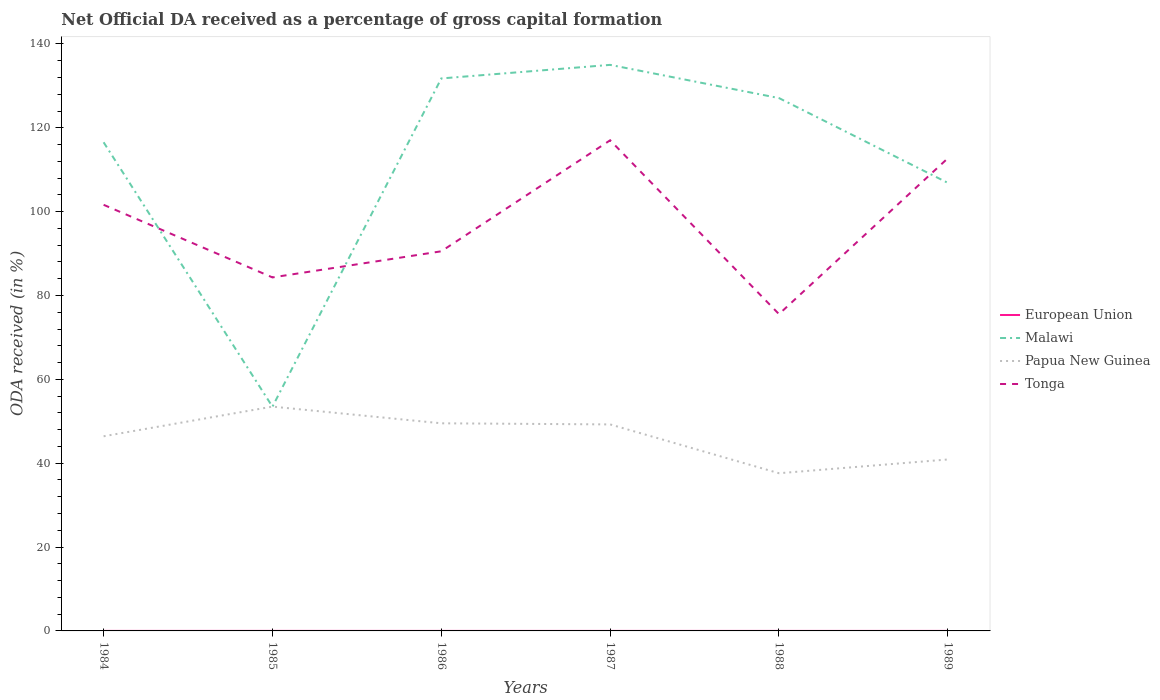Is the number of lines equal to the number of legend labels?
Offer a very short reply. Yes. Across all years, what is the maximum net ODA received in Papua New Guinea?
Your answer should be compact. 37.61. In which year was the net ODA received in European Union maximum?
Make the answer very short. 1989. What is the total net ODA received in Malawi in the graph?
Your answer should be compact. -53.38. What is the difference between the highest and the second highest net ODA received in Papua New Guinea?
Ensure brevity in your answer.  15.89. Is the net ODA received in Papua New Guinea strictly greater than the net ODA received in Malawi over the years?
Keep it short and to the point. No. How many lines are there?
Your response must be concise. 4. How many years are there in the graph?
Offer a very short reply. 6. What is the difference between two consecutive major ticks on the Y-axis?
Make the answer very short. 20. Are the values on the major ticks of Y-axis written in scientific E-notation?
Offer a terse response. No. Does the graph contain grids?
Your answer should be compact. No. What is the title of the graph?
Give a very brief answer. Net Official DA received as a percentage of gross capital formation. Does "Morocco" appear as one of the legend labels in the graph?
Provide a short and direct response. No. What is the label or title of the Y-axis?
Offer a terse response. ODA received (in %). What is the ODA received (in %) in European Union in 1984?
Keep it short and to the point. 0. What is the ODA received (in %) in Malawi in 1984?
Your response must be concise. 116.54. What is the ODA received (in %) of Papua New Guinea in 1984?
Your answer should be compact. 46.42. What is the ODA received (in %) of Tonga in 1984?
Offer a very short reply. 101.63. What is the ODA received (in %) of European Union in 1985?
Your answer should be compact. 0.01. What is the ODA received (in %) of Malawi in 1985?
Give a very brief answer. 53.48. What is the ODA received (in %) in Papua New Guinea in 1985?
Keep it short and to the point. 53.5. What is the ODA received (in %) in Tonga in 1985?
Your response must be concise. 84.31. What is the ODA received (in %) in European Union in 1986?
Keep it short and to the point. 0. What is the ODA received (in %) in Malawi in 1986?
Offer a terse response. 131.77. What is the ODA received (in %) in Papua New Guinea in 1986?
Ensure brevity in your answer.  49.52. What is the ODA received (in %) in Tonga in 1986?
Offer a terse response. 90.54. What is the ODA received (in %) in European Union in 1987?
Offer a very short reply. 0. What is the ODA received (in %) of Malawi in 1987?
Offer a very short reply. 135. What is the ODA received (in %) in Papua New Guinea in 1987?
Offer a very short reply. 49.25. What is the ODA received (in %) in Tonga in 1987?
Provide a succinct answer. 117.01. What is the ODA received (in %) of European Union in 1988?
Offer a very short reply. 0. What is the ODA received (in %) of Malawi in 1988?
Keep it short and to the point. 127.08. What is the ODA received (in %) of Papua New Guinea in 1988?
Make the answer very short. 37.61. What is the ODA received (in %) of Tonga in 1988?
Offer a terse response. 75.56. What is the ODA received (in %) in European Union in 1989?
Make the answer very short. 0. What is the ODA received (in %) of Malawi in 1989?
Your answer should be compact. 106.86. What is the ODA received (in %) in Papua New Guinea in 1989?
Your answer should be compact. 40.89. What is the ODA received (in %) of Tonga in 1989?
Keep it short and to the point. 112.73. Across all years, what is the maximum ODA received (in %) of European Union?
Your answer should be compact. 0.01. Across all years, what is the maximum ODA received (in %) in Malawi?
Provide a short and direct response. 135. Across all years, what is the maximum ODA received (in %) in Papua New Guinea?
Give a very brief answer. 53.5. Across all years, what is the maximum ODA received (in %) in Tonga?
Provide a short and direct response. 117.01. Across all years, what is the minimum ODA received (in %) in European Union?
Your answer should be very brief. 0. Across all years, what is the minimum ODA received (in %) in Malawi?
Give a very brief answer. 53.48. Across all years, what is the minimum ODA received (in %) of Papua New Guinea?
Offer a terse response. 37.61. Across all years, what is the minimum ODA received (in %) of Tonga?
Offer a very short reply. 75.56. What is the total ODA received (in %) in European Union in the graph?
Give a very brief answer. 0.02. What is the total ODA received (in %) in Malawi in the graph?
Your response must be concise. 670.73. What is the total ODA received (in %) of Papua New Guinea in the graph?
Provide a succinct answer. 277.19. What is the total ODA received (in %) in Tonga in the graph?
Give a very brief answer. 581.78. What is the difference between the ODA received (in %) in European Union in 1984 and that in 1985?
Your answer should be very brief. -0. What is the difference between the ODA received (in %) of Malawi in 1984 and that in 1985?
Ensure brevity in your answer.  63.06. What is the difference between the ODA received (in %) of Papua New Guinea in 1984 and that in 1985?
Provide a succinct answer. -7.08. What is the difference between the ODA received (in %) in Tonga in 1984 and that in 1985?
Provide a short and direct response. 17.32. What is the difference between the ODA received (in %) of European Union in 1984 and that in 1986?
Give a very brief answer. -0. What is the difference between the ODA received (in %) of Malawi in 1984 and that in 1986?
Your answer should be very brief. -15.22. What is the difference between the ODA received (in %) of Papua New Guinea in 1984 and that in 1986?
Your answer should be compact. -3.09. What is the difference between the ODA received (in %) in Tonga in 1984 and that in 1986?
Give a very brief answer. 11.09. What is the difference between the ODA received (in %) of European Union in 1984 and that in 1987?
Offer a very short reply. 0. What is the difference between the ODA received (in %) in Malawi in 1984 and that in 1987?
Your answer should be compact. -18.46. What is the difference between the ODA received (in %) in Papua New Guinea in 1984 and that in 1987?
Your answer should be very brief. -2.83. What is the difference between the ODA received (in %) of Tonga in 1984 and that in 1987?
Provide a succinct answer. -15.39. What is the difference between the ODA received (in %) of European Union in 1984 and that in 1988?
Your response must be concise. 0. What is the difference between the ODA received (in %) in Malawi in 1984 and that in 1988?
Your answer should be compact. -10.54. What is the difference between the ODA received (in %) of Papua New Guinea in 1984 and that in 1988?
Give a very brief answer. 8.81. What is the difference between the ODA received (in %) in Tonga in 1984 and that in 1988?
Your answer should be compact. 26.07. What is the difference between the ODA received (in %) of European Union in 1984 and that in 1989?
Make the answer very short. 0. What is the difference between the ODA received (in %) of Malawi in 1984 and that in 1989?
Offer a very short reply. 9.68. What is the difference between the ODA received (in %) in Papua New Guinea in 1984 and that in 1989?
Give a very brief answer. 5.53. What is the difference between the ODA received (in %) of Tonga in 1984 and that in 1989?
Your response must be concise. -11.1. What is the difference between the ODA received (in %) of European Union in 1985 and that in 1986?
Your answer should be compact. 0. What is the difference between the ODA received (in %) in Malawi in 1985 and that in 1986?
Make the answer very short. -78.29. What is the difference between the ODA received (in %) of Papua New Guinea in 1985 and that in 1986?
Offer a very short reply. 3.98. What is the difference between the ODA received (in %) in Tonga in 1985 and that in 1986?
Provide a short and direct response. -6.23. What is the difference between the ODA received (in %) of European Union in 1985 and that in 1987?
Make the answer very short. 0. What is the difference between the ODA received (in %) in Malawi in 1985 and that in 1987?
Your response must be concise. -81.52. What is the difference between the ODA received (in %) of Papua New Guinea in 1985 and that in 1987?
Ensure brevity in your answer.  4.25. What is the difference between the ODA received (in %) in Tonga in 1985 and that in 1987?
Provide a short and direct response. -32.7. What is the difference between the ODA received (in %) of European Union in 1985 and that in 1988?
Keep it short and to the point. 0. What is the difference between the ODA received (in %) of Malawi in 1985 and that in 1988?
Give a very brief answer. -73.6. What is the difference between the ODA received (in %) in Papua New Guinea in 1985 and that in 1988?
Offer a terse response. 15.89. What is the difference between the ODA received (in %) in Tonga in 1985 and that in 1988?
Your answer should be very brief. 8.75. What is the difference between the ODA received (in %) of European Union in 1985 and that in 1989?
Offer a terse response. 0.01. What is the difference between the ODA received (in %) in Malawi in 1985 and that in 1989?
Offer a very short reply. -53.38. What is the difference between the ODA received (in %) of Papua New Guinea in 1985 and that in 1989?
Your answer should be very brief. 12.61. What is the difference between the ODA received (in %) in Tonga in 1985 and that in 1989?
Keep it short and to the point. -28.42. What is the difference between the ODA received (in %) in Malawi in 1986 and that in 1987?
Keep it short and to the point. -3.24. What is the difference between the ODA received (in %) of Papua New Guinea in 1986 and that in 1987?
Offer a very short reply. 0.27. What is the difference between the ODA received (in %) in Tonga in 1986 and that in 1987?
Give a very brief answer. -26.47. What is the difference between the ODA received (in %) of European Union in 1986 and that in 1988?
Provide a short and direct response. 0. What is the difference between the ODA received (in %) of Malawi in 1986 and that in 1988?
Your response must be concise. 4.68. What is the difference between the ODA received (in %) in Papua New Guinea in 1986 and that in 1988?
Make the answer very short. 11.91. What is the difference between the ODA received (in %) of Tonga in 1986 and that in 1988?
Offer a terse response. 14.98. What is the difference between the ODA received (in %) in European Union in 1986 and that in 1989?
Keep it short and to the point. 0. What is the difference between the ODA received (in %) in Malawi in 1986 and that in 1989?
Provide a short and direct response. 24.9. What is the difference between the ODA received (in %) of Papua New Guinea in 1986 and that in 1989?
Keep it short and to the point. 8.63. What is the difference between the ODA received (in %) in Tonga in 1986 and that in 1989?
Keep it short and to the point. -22.19. What is the difference between the ODA received (in %) in Malawi in 1987 and that in 1988?
Offer a terse response. 7.92. What is the difference between the ODA received (in %) in Papua New Guinea in 1987 and that in 1988?
Give a very brief answer. 11.64. What is the difference between the ODA received (in %) in Tonga in 1987 and that in 1988?
Give a very brief answer. 41.46. What is the difference between the ODA received (in %) in European Union in 1987 and that in 1989?
Offer a terse response. 0. What is the difference between the ODA received (in %) in Malawi in 1987 and that in 1989?
Your answer should be very brief. 28.14. What is the difference between the ODA received (in %) of Papua New Guinea in 1987 and that in 1989?
Offer a terse response. 8.36. What is the difference between the ODA received (in %) in Tonga in 1987 and that in 1989?
Make the answer very short. 4.29. What is the difference between the ODA received (in %) of European Union in 1988 and that in 1989?
Your answer should be compact. 0. What is the difference between the ODA received (in %) of Malawi in 1988 and that in 1989?
Offer a terse response. 20.22. What is the difference between the ODA received (in %) of Papua New Guinea in 1988 and that in 1989?
Provide a succinct answer. -3.28. What is the difference between the ODA received (in %) in Tonga in 1988 and that in 1989?
Make the answer very short. -37.17. What is the difference between the ODA received (in %) of European Union in 1984 and the ODA received (in %) of Malawi in 1985?
Your answer should be very brief. -53.48. What is the difference between the ODA received (in %) of European Union in 1984 and the ODA received (in %) of Papua New Guinea in 1985?
Offer a very short reply. -53.49. What is the difference between the ODA received (in %) in European Union in 1984 and the ODA received (in %) in Tonga in 1985?
Your answer should be very brief. -84.31. What is the difference between the ODA received (in %) of Malawi in 1984 and the ODA received (in %) of Papua New Guinea in 1985?
Make the answer very short. 63.04. What is the difference between the ODA received (in %) of Malawi in 1984 and the ODA received (in %) of Tonga in 1985?
Your answer should be compact. 32.23. What is the difference between the ODA received (in %) in Papua New Guinea in 1984 and the ODA received (in %) in Tonga in 1985?
Keep it short and to the point. -37.89. What is the difference between the ODA received (in %) of European Union in 1984 and the ODA received (in %) of Malawi in 1986?
Give a very brief answer. -131.76. What is the difference between the ODA received (in %) in European Union in 1984 and the ODA received (in %) in Papua New Guinea in 1986?
Your answer should be compact. -49.51. What is the difference between the ODA received (in %) of European Union in 1984 and the ODA received (in %) of Tonga in 1986?
Keep it short and to the point. -90.54. What is the difference between the ODA received (in %) of Malawi in 1984 and the ODA received (in %) of Papua New Guinea in 1986?
Ensure brevity in your answer.  67.02. What is the difference between the ODA received (in %) of Malawi in 1984 and the ODA received (in %) of Tonga in 1986?
Provide a succinct answer. 26. What is the difference between the ODA received (in %) of Papua New Guinea in 1984 and the ODA received (in %) of Tonga in 1986?
Ensure brevity in your answer.  -44.12. What is the difference between the ODA received (in %) in European Union in 1984 and the ODA received (in %) in Malawi in 1987?
Your response must be concise. -135. What is the difference between the ODA received (in %) of European Union in 1984 and the ODA received (in %) of Papua New Guinea in 1987?
Ensure brevity in your answer.  -49.25. What is the difference between the ODA received (in %) in European Union in 1984 and the ODA received (in %) in Tonga in 1987?
Give a very brief answer. -117.01. What is the difference between the ODA received (in %) in Malawi in 1984 and the ODA received (in %) in Papua New Guinea in 1987?
Offer a terse response. 67.29. What is the difference between the ODA received (in %) in Malawi in 1984 and the ODA received (in %) in Tonga in 1987?
Provide a short and direct response. -0.47. What is the difference between the ODA received (in %) of Papua New Guinea in 1984 and the ODA received (in %) of Tonga in 1987?
Keep it short and to the point. -70.59. What is the difference between the ODA received (in %) in European Union in 1984 and the ODA received (in %) in Malawi in 1988?
Offer a very short reply. -127.08. What is the difference between the ODA received (in %) in European Union in 1984 and the ODA received (in %) in Papua New Guinea in 1988?
Keep it short and to the point. -37.61. What is the difference between the ODA received (in %) in European Union in 1984 and the ODA received (in %) in Tonga in 1988?
Ensure brevity in your answer.  -75.55. What is the difference between the ODA received (in %) of Malawi in 1984 and the ODA received (in %) of Papua New Guinea in 1988?
Offer a very short reply. 78.93. What is the difference between the ODA received (in %) in Malawi in 1984 and the ODA received (in %) in Tonga in 1988?
Your answer should be very brief. 40.98. What is the difference between the ODA received (in %) in Papua New Guinea in 1984 and the ODA received (in %) in Tonga in 1988?
Ensure brevity in your answer.  -29.13. What is the difference between the ODA received (in %) in European Union in 1984 and the ODA received (in %) in Malawi in 1989?
Keep it short and to the point. -106.86. What is the difference between the ODA received (in %) of European Union in 1984 and the ODA received (in %) of Papua New Guinea in 1989?
Provide a succinct answer. -40.89. What is the difference between the ODA received (in %) in European Union in 1984 and the ODA received (in %) in Tonga in 1989?
Provide a short and direct response. -112.72. What is the difference between the ODA received (in %) of Malawi in 1984 and the ODA received (in %) of Papua New Guinea in 1989?
Make the answer very short. 75.65. What is the difference between the ODA received (in %) of Malawi in 1984 and the ODA received (in %) of Tonga in 1989?
Your answer should be compact. 3.81. What is the difference between the ODA received (in %) in Papua New Guinea in 1984 and the ODA received (in %) in Tonga in 1989?
Offer a terse response. -66.31. What is the difference between the ODA received (in %) in European Union in 1985 and the ODA received (in %) in Malawi in 1986?
Give a very brief answer. -131.76. What is the difference between the ODA received (in %) in European Union in 1985 and the ODA received (in %) in Papua New Guinea in 1986?
Provide a succinct answer. -49.51. What is the difference between the ODA received (in %) in European Union in 1985 and the ODA received (in %) in Tonga in 1986?
Provide a succinct answer. -90.53. What is the difference between the ODA received (in %) of Malawi in 1985 and the ODA received (in %) of Papua New Guinea in 1986?
Offer a terse response. 3.96. What is the difference between the ODA received (in %) of Malawi in 1985 and the ODA received (in %) of Tonga in 1986?
Your answer should be very brief. -37.06. What is the difference between the ODA received (in %) in Papua New Guinea in 1985 and the ODA received (in %) in Tonga in 1986?
Your response must be concise. -37.04. What is the difference between the ODA received (in %) in European Union in 1985 and the ODA received (in %) in Malawi in 1987?
Ensure brevity in your answer.  -134.99. What is the difference between the ODA received (in %) of European Union in 1985 and the ODA received (in %) of Papua New Guinea in 1987?
Provide a short and direct response. -49.24. What is the difference between the ODA received (in %) of European Union in 1985 and the ODA received (in %) of Tonga in 1987?
Provide a succinct answer. -117.01. What is the difference between the ODA received (in %) of Malawi in 1985 and the ODA received (in %) of Papua New Guinea in 1987?
Give a very brief answer. 4.23. What is the difference between the ODA received (in %) in Malawi in 1985 and the ODA received (in %) in Tonga in 1987?
Keep it short and to the point. -63.53. What is the difference between the ODA received (in %) in Papua New Guinea in 1985 and the ODA received (in %) in Tonga in 1987?
Give a very brief answer. -63.52. What is the difference between the ODA received (in %) of European Union in 1985 and the ODA received (in %) of Malawi in 1988?
Offer a very short reply. -127.08. What is the difference between the ODA received (in %) in European Union in 1985 and the ODA received (in %) in Papua New Guinea in 1988?
Your answer should be very brief. -37.6. What is the difference between the ODA received (in %) in European Union in 1985 and the ODA received (in %) in Tonga in 1988?
Your answer should be very brief. -75.55. What is the difference between the ODA received (in %) in Malawi in 1985 and the ODA received (in %) in Papua New Guinea in 1988?
Your answer should be very brief. 15.87. What is the difference between the ODA received (in %) of Malawi in 1985 and the ODA received (in %) of Tonga in 1988?
Keep it short and to the point. -22.08. What is the difference between the ODA received (in %) in Papua New Guinea in 1985 and the ODA received (in %) in Tonga in 1988?
Your response must be concise. -22.06. What is the difference between the ODA received (in %) in European Union in 1985 and the ODA received (in %) in Malawi in 1989?
Keep it short and to the point. -106.85. What is the difference between the ODA received (in %) in European Union in 1985 and the ODA received (in %) in Papua New Guinea in 1989?
Offer a very short reply. -40.88. What is the difference between the ODA received (in %) in European Union in 1985 and the ODA received (in %) in Tonga in 1989?
Ensure brevity in your answer.  -112.72. What is the difference between the ODA received (in %) of Malawi in 1985 and the ODA received (in %) of Papua New Guinea in 1989?
Make the answer very short. 12.59. What is the difference between the ODA received (in %) in Malawi in 1985 and the ODA received (in %) in Tonga in 1989?
Keep it short and to the point. -59.25. What is the difference between the ODA received (in %) of Papua New Guinea in 1985 and the ODA received (in %) of Tonga in 1989?
Offer a terse response. -59.23. What is the difference between the ODA received (in %) in European Union in 1986 and the ODA received (in %) in Malawi in 1987?
Your response must be concise. -135. What is the difference between the ODA received (in %) in European Union in 1986 and the ODA received (in %) in Papua New Guinea in 1987?
Make the answer very short. -49.25. What is the difference between the ODA received (in %) in European Union in 1986 and the ODA received (in %) in Tonga in 1987?
Offer a terse response. -117.01. What is the difference between the ODA received (in %) of Malawi in 1986 and the ODA received (in %) of Papua New Guinea in 1987?
Make the answer very short. 82.51. What is the difference between the ODA received (in %) in Malawi in 1986 and the ODA received (in %) in Tonga in 1987?
Your answer should be compact. 14.75. What is the difference between the ODA received (in %) in Papua New Guinea in 1986 and the ODA received (in %) in Tonga in 1987?
Your answer should be very brief. -67.5. What is the difference between the ODA received (in %) of European Union in 1986 and the ODA received (in %) of Malawi in 1988?
Provide a short and direct response. -127.08. What is the difference between the ODA received (in %) in European Union in 1986 and the ODA received (in %) in Papua New Guinea in 1988?
Provide a succinct answer. -37.61. What is the difference between the ODA received (in %) of European Union in 1986 and the ODA received (in %) of Tonga in 1988?
Provide a succinct answer. -75.55. What is the difference between the ODA received (in %) of Malawi in 1986 and the ODA received (in %) of Papua New Guinea in 1988?
Ensure brevity in your answer.  94.16. What is the difference between the ODA received (in %) in Malawi in 1986 and the ODA received (in %) in Tonga in 1988?
Keep it short and to the point. 56.21. What is the difference between the ODA received (in %) in Papua New Guinea in 1986 and the ODA received (in %) in Tonga in 1988?
Ensure brevity in your answer.  -26.04. What is the difference between the ODA received (in %) of European Union in 1986 and the ODA received (in %) of Malawi in 1989?
Your answer should be very brief. -106.86. What is the difference between the ODA received (in %) of European Union in 1986 and the ODA received (in %) of Papua New Guinea in 1989?
Provide a succinct answer. -40.89. What is the difference between the ODA received (in %) in European Union in 1986 and the ODA received (in %) in Tonga in 1989?
Your response must be concise. -112.72. What is the difference between the ODA received (in %) in Malawi in 1986 and the ODA received (in %) in Papua New Guinea in 1989?
Give a very brief answer. 90.88. What is the difference between the ODA received (in %) of Malawi in 1986 and the ODA received (in %) of Tonga in 1989?
Make the answer very short. 19.04. What is the difference between the ODA received (in %) of Papua New Guinea in 1986 and the ODA received (in %) of Tonga in 1989?
Provide a short and direct response. -63.21. What is the difference between the ODA received (in %) in European Union in 1987 and the ODA received (in %) in Malawi in 1988?
Give a very brief answer. -127.08. What is the difference between the ODA received (in %) in European Union in 1987 and the ODA received (in %) in Papua New Guinea in 1988?
Your answer should be very brief. -37.61. What is the difference between the ODA received (in %) in European Union in 1987 and the ODA received (in %) in Tonga in 1988?
Your answer should be very brief. -75.55. What is the difference between the ODA received (in %) in Malawi in 1987 and the ODA received (in %) in Papua New Guinea in 1988?
Provide a succinct answer. 97.39. What is the difference between the ODA received (in %) of Malawi in 1987 and the ODA received (in %) of Tonga in 1988?
Ensure brevity in your answer.  59.44. What is the difference between the ODA received (in %) in Papua New Guinea in 1987 and the ODA received (in %) in Tonga in 1988?
Offer a very short reply. -26.31. What is the difference between the ODA received (in %) in European Union in 1987 and the ODA received (in %) in Malawi in 1989?
Give a very brief answer. -106.86. What is the difference between the ODA received (in %) of European Union in 1987 and the ODA received (in %) of Papua New Guinea in 1989?
Make the answer very short. -40.89. What is the difference between the ODA received (in %) of European Union in 1987 and the ODA received (in %) of Tonga in 1989?
Offer a very short reply. -112.72. What is the difference between the ODA received (in %) in Malawi in 1987 and the ODA received (in %) in Papua New Guinea in 1989?
Keep it short and to the point. 94.11. What is the difference between the ODA received (in %) of Malawi in 1987 and the ODA received (in %) of Tonga in 1989?
Ensure brevity in your answer.  22.27. What is the difference between the ODA received (in %) in Papua New Guinea in 1987 and the ODA received (in %) in Tonga in 1989?
Offer a very short reply. -63.48. What is the difference between the ODA received (in %) of European Union in 1988 and the ODA received (in %) of Malawi in 1989?
Offer a terse response. -106.86. What is the difference between the ODA received (in %) in European Union in 1988 and the ODA received (in %) in Papua New Guinea in 1989?
Provide a short and direct response. -40.89. What is the difference between the ODA received (in %) in European Union in 1988 and the ODA received (in %) in Tonga in 1989?
Your response must be concise. -112.73. What is the difference between the ODA received (in %) in Malawi in 1988 and the ODA received (in %) in Papua New Guinea in 1989?
Provide a succinct answer. 86.19. What is the difference between the ODA received (in %) in Malawi in 1988 and the ODA received (in %) in Tonga in 1989?
Offer a terse response. 14.36. What is the difference between the ODA received (in %) of Papua New Guinea in 1988 and the ODA received (in %) of Tonga in 1989?
Provide a succinct answer. -75.12. What is the average ODA received (in %) of European Union per year?
Your response must be concise. 0. What is the average ODA received (in %) in Malawi per year?
Ensure brevity in your answer.  111.79. What is the average ODA received (in %) of Papua New Guinea per year?
Offer a very short reply. 46.2. What is the average ODA received (in %) in Tonga per year?
Your answer should be very brief. 96.96. In the year 1984, what is the difference between the ODA received (in %) in European Union and ODA received (in %) in Malawi?
Give a very brief answer. -116.54. In the year 1984, what is the difference between the ODA received (in %) of European Union and ODA received (in %) of Papua New Guinea?
Give a very brief answer. -46.42. In the year 1984, what is the difference between the ODA received (in %) in European Union and ODA received (in %) in Tonga?
Your answer should be compact. -101.62. In the year 1984, what is the difference between the ODA received (in %) in Malawi and ODA received (in %) in Papua New Guinea?
Ensure brevity in your answer.  70.12. In the year 1984, what is the difference between the ODA received (in %) in Malawi and ODA received (in %) in Tonga?
Offer a very short reply. 14.91. In the year 1984, what is the difference between the ODA received (in %) in Papua New Guinea and ODA received (in %) in Tonga?
Make the answer very short. -55.21. In the year 1985, what is the difference between the ODA received (in %) of European Union and ODA received (in %) of Malawi?
Your answer should be compact. -53.47. In the year 1985, what is the difference between the ODA received (in %) in European Union and ODA received (in %) in Papua New Guinea?
Your answer should be compact. -53.49. In the year 1985, what is the difference between the ODA received (in %) of European Union and ODA received (in %) of Tonga?
Give a very brief answer. -84.3. In the year 1985, what is the difference between the ODA received (in %) of Malawi and ODA received (in %) of Papua New Guinea?
Keep it short and to the point. -0.02. In the year 1985, what is the difference between the ODA received (in %) in Malawi and ODA received (in %) in Tonga?
Make the answer very short. -30.83. In the year 1985, what is the difference between the ODA received (in %) in Papua New Guinea and ODA received (in %) in Tonga?
Your answer should be very brief. -30.81. In the year 1986, what is the difference between the ODA received (in %) of European Union and ODA received (in %) of Malawi?
Ensure brevity in your answer.  -131.76. In the year 1986, what is the difference between the ODA received (in %) in European Union and ODA received (in %) in Papua New Guinea?
Your answer should be compact. -49.51. In the year 1986, what is the difference between the ODA received (in %) in European Union and ODA received (in %) in Tonga?
Your answer should be compact. -90.54. In the year 1986, what is the difference between the ODA received (in %) in Malawi and ODA received (in %) in Papua New Guinea?
Make the answer very short. 82.25. In the year 1986, what is the difference between the ODA received (in %) in Malawi and ODA received (in %) in Tonga?
Keep it short and to the point. 41.22. In the year 1986, what is the difference between the ODA received (in %) in Papua New Guinea and ODA received (in %) in Tonga?
Offer a very short reply. -41.02. In the year 1987, what is the difference between the ODA received (in %) in European Union and ODA received (in %) in Malawi?
Give a very brief answer. -135. In the year 1987, what is the difference between the ODA received (in %) of European Union and ODA received (in %) of Papua New Guinea?
Keep it short and to the point. -49.25. In the year 1987, what is the difference between the ODA received (in %) of European Union and ODA received (in %) of Tonga?
Your response must be concise. -117.01. In the year 1987, what is the difference between the ODA received (in %) of Malawi and ODA received (in %) of Papua New Guinea?
Ensure brevity in your answer.  85.75. In the year 1987, what is the difference between the ODA received (in %) of Malawi and ODA received (in %) of Tonga?
Your response must be concise. 17.99. In the year 1987, what is the difference between the ODA received (in %) of Papua New Guinea and ODA received (in %) of Tonga?
Your answer should be very brief. -67.76. In the year 1988, what is the difference between the ODA received (in %) of European Union and ODA received (in %) of Malawi?
Ensure brevity in your answer.  -127.08. In the year 1988, what is the difference between the ODA received (in %) of European Union and ODA received (in %) of Papua New Guinea?
Provide a succinct answer. -37.61. In the year 1988, what is the difference between the ODA received (in %) in European Union and ODA received (in %) in Tonga?
Provide a short and direct response. -75.55. In the year 1988, what is the difference between the ODA received (in %) of Malawi and ODA received (in %) of Papua New Guinea?
Your answer should be very brief. 89.47. In the year 1988, what is the difference between the ODA received (in %) in Malawi and ODA received (in %) in Tonga?
Your response must be concise. 51.53. In the year 1988, what is the difference between the ODA received (in %) in Papua New Guinea and ODA received (in %) in Tonga?
Keep it short and to the point. -37.95. In the year 1989, what is the difference between the ODA received (in %) of European Union and ODA received (in %) of Malawi?
Your response must be concise. -106.86. In the year 1989, what is the difference between the ODA received (in %) of European Union and ODA received (in %) of Papua New Guinea?
Give a very brief answer. -40.89. In the year 1989, what is the difference between the ODA received (in %) in European Union and ODA received (in %) in Tonga?
Offer a terse response. -112.73. In the year 1989, what is the difference between the ODA received (in %) of Malawi and ODA received (in %) of Papua New Guinea?
Your answer should be compact. 65.97. In the year 1989, what is the difference between the ODA received (in %) in Malawi and ODA received (in %) in Tonga?
Ensure brevity in your answer.  -5.87. In the year 1989, what is the difference between the ODA received (in %) of Papua New Guinea and ODA received (in %) of Tonga?
Ensure brevity in your answer.  -71.84. What is the ratio of the ODA received (in %) of European Union in 1984 to that in 1985?
Provide a succinct answer. 0.53. What is the ratio of the ODA received (in %) in Malawi in 1984 to that in 1985?
Offer a terse response. 2.18. What is the ratio of the ODA received (in %) of Papua New Guinea in 1984 to that in 1985?
Make the answer very short. 0.87. What is the ratio of the ODA received (in %) of Tonga in 1984 to that in 1985?
Ensure brevity in your answer.  1.21. What is the ratio of the ODA received (in %) of European Union in 1984 to that in 1986?
Provide a short and direct response. 0.95. What is the ratio of the ODA received (in %) of Malawi in 1984 to that in 1986?
Offer a terse response. 0.88. What is the ratio of the ODA received (in %) of Tonga in 1984 to that in 1986?
Make the answer very short. 1.12. What is the ratio of the ODA received (in %) in European Union in 1984 to that in 1987?
Offer a terse response. 1.24. What is the ratio of the ODA received (in %) in Malawi in 1984 to that in 1987?
Your response must be concise. 0.86. What is the ratio of the ODA received (in %) of Papua New Guinea in 1984 to that in 1987?
Offer a terse response. 0.94. What is the ratio of the ODA received (in %) in Tonga in 1984 to that in 1987?
Offer a very short reply. 0.87. What is the ratio of the ODA received (in %) of European Union in 1984 to that in 1988?
Offer a terse response. 1.41. What is the ratio of the ODA received (in %) in Malawi in 1984 to that in 1988?
Offer a very short reply. 0.92. What is the ratio of the ODA received (in %) in Papua New Guinea in 1984 to that in 1988?
Make the answer very short. 1.23. What is the ratio of the ODA received (in %) in Tonga in 1984 to that in 1988?
Ensure brevity in your answer.  1.35. What is the ratio of the ODA received (in %) of European Union in 1984 to that in 1989?
Your answer should be very brief. 1.73. What is the ratio of the ODA received (in %) in Malawi in 1984 to that in 1989?
Provide a succinct answer. 1.09. What is the ratio of the ODA received (in %) of Papua New Guinea in 1984 to that in 1989?
Your response must be concise. 1.14. What is the ratio of the ODA received (in %) of Tonga in 1984 to that in 1989?
Your answer should be compact. 0.9. What is the ratio of the ODA received (in %) in European Union in 1985 to that in 1986?
Your answer should be compact. 1.8. What is the ratio of the ODA received (in %) in Malawi in 1985 to that in 1986?
Offer a terse response. 0.41. What is the ratio of the ODA received (in %) in Papua New Guinea in 1985 to that in 1986?
Your answer should be compact. 1.08. What is the ratio of the ODA received (in %) of Tonga in 1985 to that in 1986?
Provide a succinct answer. 0.93. What is the ratio of the ODA received (in %) in European Union in 1985 to that in 1987?
Your answer should be compact. 2.36. What is the ratio of the ODA received (in %) of Malawi in 1985 to that in 1987?
Your response must be concise. 0.4. What is the ratio of the ODA received (in %) in Papua New Guinea in 1985 to that in 1987?
Ensure brevity in your answer.  1.09. What is the ratio of the ODA received (in %) of Tonga in 1985 to that in 1987?
Your response must be concise. 0.72. What is the ratio of the ODA received (in %) of European Union in 1985 to that in 1988?
Your response must be concise. 2.68. What is the ratio of the ODA received (in %) in Malawi in 1985 to that in 1988?
Give a very brief answer. 0.42. What is the ratio of the ODA received (in %) in Papua New Guinea in 1985 to that in 1988?
Provide a succinct answer. 1.42. What is the ratio of the ODA received (in %) in Tonga in 1985 to that in 1988?
Your answer should be very brief. 1.12. What is the ratio of the ODA received (in %) of European Union in 1985 to that in 1989?
Make the answer very short. 3.3. What is the ratio of the ODA received (in %) of Malawi in 1985 to that in 1989?
Offer a very short reply. 0.5. What is the ratio of the ODA received (in %) in Papua New Guinea in 1985 to that in 1989?
Provide a short and direct response. 1.31. What is the ratio of the ODA received (in %) of Tonga in 1985 to that in 1989?
Your answer should be compact. 0.75. What is the ratio of the ODA received (in %) in European Union in 1986 to that in 1987?
Your answer should be compact. 1.31. What is the ratio of the ODA received (in %) in Papua New Guinea in 1986 to that in 1987?
Your answer should be very brief. 1.01. What is the ratio of the ODA received (in %) of Tonga in 1986 to that in 1987?
Your response must be concise. 0.77. What is the ratio of the ODA received (in %) of European Union in 1986 to that in 1988?
Make the answer very short. 1.49. What is the ratio of the ODA received (in %) in Malawi in 1986 to that in 1988?
Give a very brief answer. 1.04. What is the ratio of the ODA received (in %) in Papua New Guinea in 1986 to that in 1988?
Make the answer very short. 1.32. What is the ratio of the ODA received (in %) of Tonga in 1986 to that in 1988?
Your answer should be very brief. 1.2. What is the ratio of the ODA received (in %) in European Union in 1986 to that in 1989?
Offer a terse response. 1.83. What is the ratio of the ODA received (in %) of Malawi in 1986 to that in 1989?
Give a very brief answer. 1.23. What is the ratio of the ODA received (in %) of Papua New Guinea in 1986 to that in 1989?
Provide a succinct answer. 1.21. What is the ratio of the ODA received (in %) in Tonga in 1986 to that in 1989?
Ensure brevity in your answer.  0.8. What is the ratio of the ODA received (in %) in European Union in 1987 to that in 1988?
Your answer should be very brief. 1.14. What is the ratio of the ODA received (in %) of Malawi in 1987 to that in 1988?
Your answer should be compact. 1.06. What is the ratio of the ODA received (in %) of Papua New Guinea in 1987 to that in 1988?
Your response must be concise. 1.31. What is the ratio of the ODA received (in %) in Tonga in 1987 to that in 1988?
Ensure brevity in your answer.  1.55. What is the ratio of the ODA received (in %) of European Union in 1987 to that in 1989?
Offer a very short reply. 1.4. What is the ratio of the ODA received (in %) of Malawi in 1987 to that in 1989?
Keep it short and to the point. 1.26. What is the ratio of the ODA received (in %) of Papua New Guinea in 1987 to that in 1989?
Your answer should be very brief. 1.2. What is the ratio of the ODA received (in %) in Tonga in 1987 to that in 1989?
Give a very brief answer. 1.04. What is the ratio of the ODA received (in %) of European Union in 1988 to that in 1989?
Make the answer very short. 1.23. What is the ratio of the ODA received (in %) in Malawi in 1988 to that in 1989?
Keep it short and to the point. 1.19. What is the ratio of the ODA received (in %) of Papua New Guinea in 1988 to that in 1989?
Ensure brevity in your answer.  0.92. What is the ratio of the ODA received (in %) in Tonga in 1988 to that in 1989?
Offer a very short reply. 0.67. What is the difference between the highest and the second highest ODA received (in %) in European Union?
Ensure brevity in your answer.  0. What is the difference between the highest and the second highest ODA received (in %) in Malawi?
Give a very brief answer. 3.24. What is the difference between the highest and the second highest ODA received (in %) of Papua New Guinea?
Make the answer very short. 3.98. What is the difference between the highest and the second highest ODA received (in %) in Tonga?
Your answer should be compact. 4.29. What is the difference between the highest and the lowest ODA received (in %) of European Union?
Your response must be concise. 0.01. What is the difference between the highest and the lowest ODA received (in %) in Malawi?
Provide a succinct answer. 81.52. What is the difference between the highest and the lowest ODA received (in %) of Papua New Guinea?
Provide a short and direct response. 15.89. What is the difference between the highest and the lowest ODA received (in %) of Tonga?
Provide a short and direct response. 41.46. 